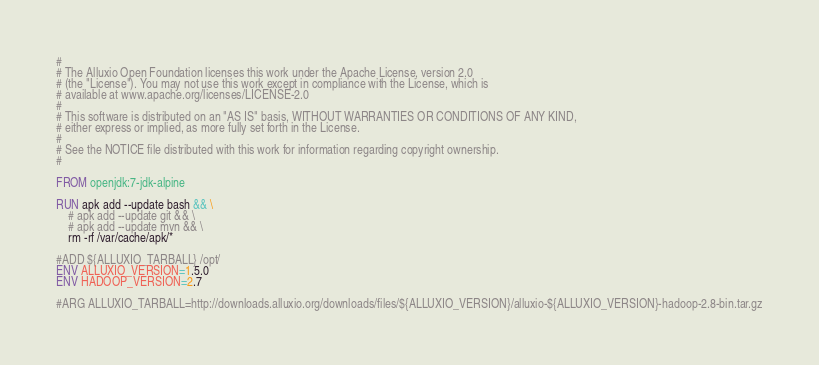<code> <loc_0><loc_0><loc_500><loc_500><_Dockerfile_>#
# The Alluxio Open Foundation licenses this work under the Apache License, version 2.0
# (the "License"). You may not use this work except in compliance with the License, which is
# available at www.apache.org/licenses/LICENSE-2.0
#
# This software is distributed on an "AS IS" basis, WITHOUT WARRANTIES OR CONDITIONS OF ANY KIND,
# either express or implied, as more fully set forth in the License.
#
# See the NOTICE file distributed with this work for information regarding copyright ownership.
#

FROM openjdk:7-jdk-alpine

RUN apk add --update bash && \
    # apk add --update git && \
    # apk add --update mvn && \
    rm -rf /var/cache/apk/*

#ADD ${ALLUXIO_TARBALL} /opt/
ENV ALLUXIO_VERSION=1.5.0
ENV HADOOP_VERSION=2.7

#ARG ALLUXIO_TARBALL=http://downloads.alluxio.org/downloads/files/${ALLUXIO_VERSION}/alluxio-${ALLUXIO_VERSION}-hadoop-2.8-bin.tar.gz</code> 